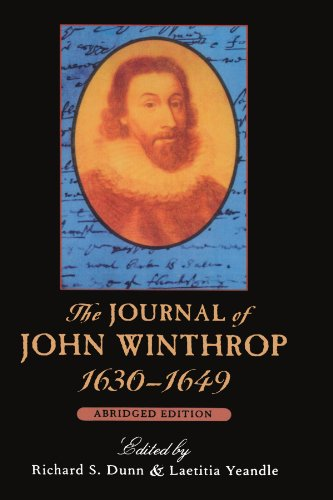Is this book related to Law? No, this book primarily deals with John Winthrop's personal and professional experiences and does not focus on legal studies or Law as a discipline. 